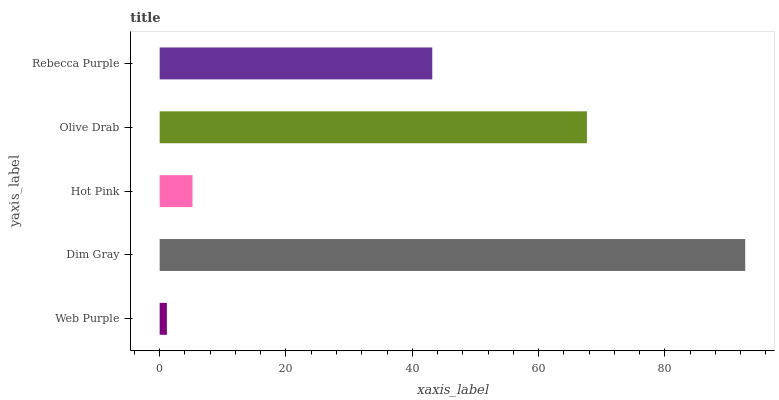Is Web Purple the minimum?
Answer yes or no. Yes. Is Dim Gray the maximum?
Answer yes or no. Yes. Is Hot Pink the minimum?
Answer yes or no. No. Is Hot Pink the maximum?
Answer yes or no. No. Is Dim Gray greater than Hot Pink?
Answer yes or no. Yes. Is Hot Pink less than Dim Gray?
Answer yes or no. Yes. Is Hot Pink greater than Dim Gray?
Answer yes or no. No. Is Dim Gray less than Hot Pink?
Answer yes or no. No. Is Rebecca Purple the high median?
Answer yes or no. Yes. Is Rebecca Purple the low median?
Answer yes or no. Yes. Is Olive Drab the high median?
Answer yes or no. No. Is Web Purple the low median?
Answer yes or no. No. 